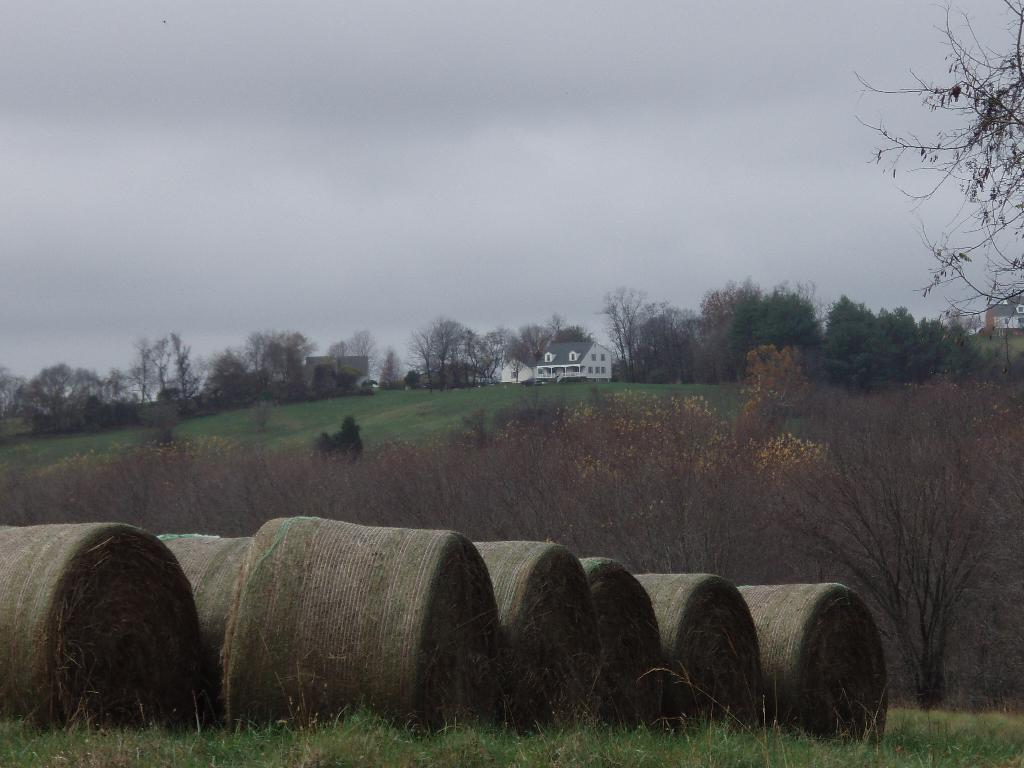What is on the ground in the image? There are objects on the ground in the image. What type of vegetation can be seen in the image? There are trees and grass in the image. What type of structures are visible in the image? There are buildings with windows in the image. What is visible in the background of the image? The sky is visible in the background of the image. What can be seen in the sky in the image? Clouds are present in the sky. How many fifths are present in the image? There is no reference to a "fifth" in the image, so it is not possible to answer that question. Can you hear the cave crying in the image? There is no cave or any indication of crying in the image. 